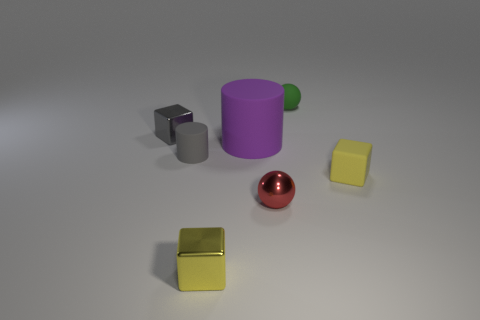How many large things are metal objects or gray rubber cylinders?
Keep it short and to the point. 0. How many things are balls in front of the tiny gray metallic cube or tiny red blocks?
Your answer should be compact. 1. What number of other things are there of the same shape as the red thing?
Ensure brevity in your answer.  1. How many green things are tiny matte things or metallic spheres?
Your response must be concise. 1. What is the color of the small block that is the same material as the big cylinder?
Ensure brevity in your answer.  Yellow. Are the small yellow block that is right of the small green sphere and the sphere in front of the gray shiny thing made of the same material?
Give a very brief answer. No. What is the material of the sphere that is behind the small gray matte cylinder?
Provide a succinct answer. Rubber. Do the yellow thing on the left side of the small green sphere and the large purple rubber thing in front of the green rubber ball have the same shape?
Give a very brief answer. No. Is there a tiny blue rubber ball?
Make the answer very short. No. There is another yellow thing that is the same shape as the yellow shiny object; what is its material?
Give a very brief answer. Rubber. 